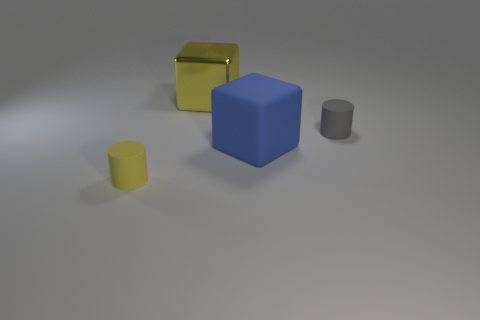Can you describe the shapes seen in the image? Certainly, the image depicts a collection of geometric shapes. From left to right, there is a small yellow cylinder, a blue cube, a tall yellow rectangular container with an open lid, and to its right, a matte grey cylinder. Which objects could potentially function as containers? From what we observe, the large yellow object, which appears to be an open-lid container, could serve that purpose. The other objects, being solid cylinders and a cube, do not exhibit any features suggesting they could contain other items. 